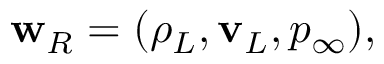Convert formula to latex. <formula><loc_0><loc_0><loc_500><loc_500>\begin{array} { r } { { w } _ { R } = ( \rho _ { L } , { v } _ { L } , p _ { \infty } ) , } \end{array}</formula> 